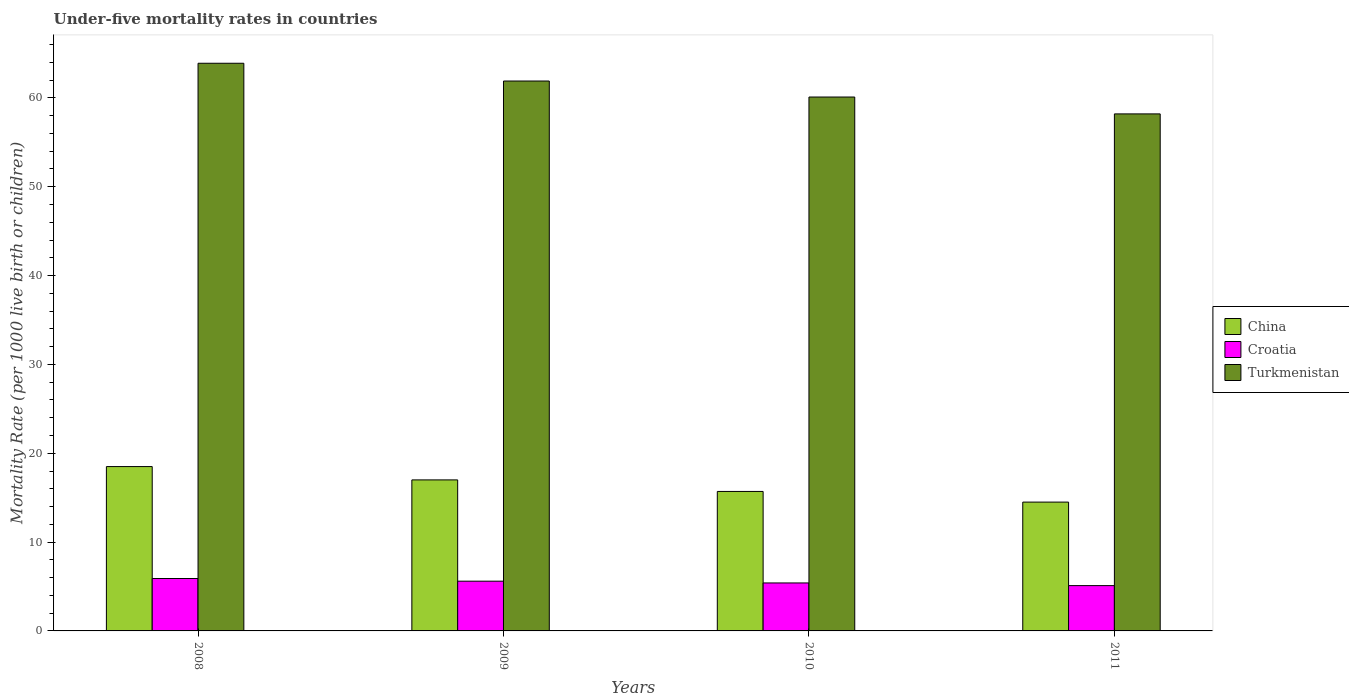How many groups of bars are there?
Give a very brief answer. 4. Are the number of bars per tick equal to the number of legend labels?
Offer a very short reply. Yes. Are the number of bars on each tick of the X-axis equal?
Make the answer very short. Yes. How many bars are there on the 1st tick from the left?
Give a very brief answer. 3. How many bars are there on the 4th tick from the right?
Ensure brevity in your answer.  3. What is the label of the 2nd group of bars from the left?
Keep it short and to the point. 2009. Across all years, what is the minimum under-five mortality rate in Croatia?
Offer a terse response. 5.1. In which year was the under-five mortality rate in Turkmenistan minimum?
Ensure brevity in your answer.  2011. What is the total under-five mortality rate in Turkmenistan in the graph?
Keep it short and to the point. 244.1. What is the difference between the under-five mortality rate in Turkmenistan in 2008 and the under-five mortality rate in China in 2011?
Ensure brevity in your answer.  49.4. What is the average under-five mortality rate in China per year?
Provide a succinct answer. 16.43. In the year 2011, what is the difference between the under-five mortality rate in Croatia and under-five mortality rate in China?
Offer a terse response. -9.4. What is the ratio of the under-five mortality rate in Croatia in 2008 to that in 2011?
Give a very brief answer. 1.16. Is the under-five mortality rate in Turkmenistan in 2009 less than that in 2010?
Your answer should be very brief. No. What is the difference between the highest and the second highest under-five mortality rate in China?
Your response must be concise. 1.5. What is the difference between the highest and the lowest under-five mortality rate in Croatia?
Provide a succinct answer. 0.8. Is the sum of the under-five mortality rate in Croatia in 2009 and 2011 greater than the maximum under-five mortality rate in China across all years?
Your answer should be compact. No. What does the 3rd bar from the left in 2010 represents?
Keep it short and to the point. Turkmenistan. What does the 1st bar from the right in 2010 represents?
Keep it short and to the point. Turkmenistan. How many years are there in the graph?
Give a very brief answer. 4. Are the values on the major ticks of Y-axis written in scientific E-notation?
Offer a terse response. No. Does the graph contain any zero values?
Ensure brevity in your answer.  No. Does the graph contain grids?
Your answer should be compact. No. Where does the legend appear in the graph?
Your response must be concise. Center right. What is the title of the graph?
Your answer should be compact. Under-five mortality rates in countries. Does "Korea (Democratic)" appear as one of the legend labels in the graph?
Offer a very short reply. No. What is the label or title of the Y-axis?
Make the answer very short. Mortality Rate (per 1000 live birth or children). What is the Mortality Rate (per 1000 live birth or children) in Turkmenistan in 2008?
Provide a short and direct response. 63.9. What is the Mortality Rate (per 1000 live birth or children) in Turkmenistan in 2009?
Your answer should be very brief. 61.9. What is the Mortality Rate (per 1000 live birth or children) of China in 2010?
Provide a short and direct response. 15.7. What is the Mortality Rate (per 1000 live birth or children) of Croatia in 2010?
Offer a very short reply. 5.4. What is the Mortality Rate (per 1000 live birth or children) of Turkmenistan in 2010?
Ensure brevity in your answer.  60.1. What is the Mortality Rate (per 1000 live birth or children) in China in 2011?
Your answer should be compact. 14.5. What is the Mortality Rate (per 1000 live birth or children) in Croatia in 2011?
Provide a succinct answer. 5.1. What is the Mortality Rate (per 1000 live birth or children) in Turkmenistan in 2011?
Offer a terse response. 58.2. Across all years, what is the maximum Mortality Rate (per 1000 live birth or children) of China?
Give a very brief answer. 18.5. Across all years, what is the maximum Mortality Rate (per 1000 live birth or children) in Croatia?
Provide a short and direct response. 5.9. Across all years, what is the maximum Mortality Rate (per 1000 live birth or children) in Turkmenistan?
Give a very brief answer. 63.9. Across all years, what is the minimum Mortality Rate (per 1000 live birth or children) of China?
Give a very brief answer. 14.5. Across all years, what is the minimum Mortality Rate (per 1000 live birth or children) of Croatia?
Your answer should be compact. 5.1. Across all years, what is the minimum Mortality Rate (per 1000 live birth or children) of Turkmenistan?
Your answer should be very brief. 58.2. What is the total Mortality Rate (per 1000 live birth or children) of China in the graph?
Your response must be concise. 65.7. What is the total Mortality Rate (per 1000 live birth or children) of Turkmenistan in the graph?
Provide a short and direct response. 244.1. What is the difference between the Mortality Rate (per 1000 live birth or children) of China in 2008 and that in 2009?
Give a very brief answer. 1.5. What is the difference between the Mortality Rate (per 1000 live birth or children) of Turkmenistan in 2008 and that in 2009?
Your answer should be compact. 2. What is the difference between the Mortality Rate (per 1000 live birth or children) of China in 2008 and that in 2010?
Provide a succinct answer. 2.8. What is the difference between the Mortality Rate (per 1000 live birth or children) in Turkmenistan in 2008 and that in 2010?
Offer a very short reply. 3.8. What is the difference between the Mortality Rate (per 1000 live birth or children) of China in 2008 and that in 2011?
Offer a terse response. 4. What is the difference between the Mortality Rate (per 1000 live birth or children) of China in 2009 and that in 2011?
Offer a very short reply. 2.5. What is the difference between the Mortality Rate (per 1000 live birth or children) in Turkmenistan in 2009 and that in 2011?
Offer a terse response. 3.7. What is the difference between the Mortality Rate (per 1000 live birth or children) in China in 2010 and that in 2011?
Your answer should be very brief. 1.2. What is the difference between the Mortality Rate (per 1000 live birth or children) in Croatia in 2010 and that in 2011?
Ensure brevity in your answer.  0.3. What is the difference between the Mortality Rate (per 1000 live birth or children) in Turkmenistan in 2010 and that in 2011?
Give a very brief answer. 1.9. What is the difference between the Mortality Rate (per 1000 live birth or children) of China in 2008 and the Mortality Rate (per 1000 live birth or children) of Turkmenistan in 2009?
Ensure brevity in your answer.  -43.4. What is the difference between the Mortality Rate (per 1000 live birth or children) in Croatia in 2008 and the Mortality Rate (per 1000 live birth or children) in Turkmenistan in 2009?
Give a very brief answer. -56. What is the difference between the Mortality Rate (per 1000 live birth or children) of China in 2008 and the Mortality Rate (per 1000 live birth or children) of Turkmenistan in 2010?
Your answer should be very brief. -41.6. What is the difference between the Mortality Rate (per 1000 live birth or children) in Croatia in 2008 and the Mortality Rate (per 1000 live birth or children) in Turkmenistan in 2010?
Provide a short and direct response. -54.2. What is the difference between the Mortality Rate (per 1000 live birth or children) in China in 2008 and the Mortality Rate (per 1000 live birth or children) in Turkmenistan in 2011?
Provide a succinct answer. -39.7. What is the difference between the Mortality Rate (per 1000 live birth or children) in Croatia in 2008 and the Mortality Rate (per 1000 live birth or children) in Turkmenistan in 2011?
Your response must be concise. -52.3. What is the difference between the Mortality Rate (per 1000 live birth or children) in China in 2009 and the Mortality Rate (per 1000 live birth or children) in Turkmenistan in 2010?
Offer a very short reply. -43.1. What is the difference between the Mortality Rate (per 1000 live birth or children) of Croatia in 2009 and the Mortality Rate (per 1000 live birth or children) of Turkmenistan in 2010?
Keep it short and to the point. -54.5. What is the difference between the Mortality Rate (per 1000 live birth or children) in China in 2009 and the Mortality Rate (per 1000 live birth or children) in Turkmenistan in 2011?
Keep it short and to the point. -41.2. What is the difference between the Mortality Rate (per 1000 live birth or children) in Croatia in 2009 and the Mortality Rate (per 1000 live birth or children) in Turkmenistan in 2011?
Your response must be concise. -52.6. What is the difference between the Mortality Rate (per 1000 live birth or children) in China in 2010 and the Mortality Rate (per 1000 live birth or children) in Croatia in 2011?
Give a very brief answer. 10.6. What is the difference between the Mortality Rate (per 1000 live birth or children) in China in 2010 and the Mortality Rate (per 1000 live birth or children) in Turkmenistan in 2011?
Your answer should be very brief. -42.5. What is the difference between the Mortality Rate (per 1000 live birth or children) of Croatia in 2010 and the Mortality Rate (per 1000 live birth or children) of Turkmenistan in 2011?
Your answer should be very brief. -52.8. What is the average Mortality Rate (per 1000 live birth or children) of China per year?
Your response must be concise. 16.43. What is the average Mortality Rate (per 1000 live birth or children) of Croatia per year?
Your response must be concise. 5.5. What is the average Mortality Rate (per 1000 live birth or children) of Turkmenistan per year?
Make the answer very short. 61.02. In the year 2008, what is the difference between the Mortality Rate (per 1000 live birth or children) in China and Mortality Rate (per 1000 live birth or children) in Croatia?
Offer a very short reply. 12.6. In the year 2008, what is the difference between the Mortality Rate (per 1000 live birth or children) in China and Mortality Rate (per 1000 live birth or children) in Turkmenistan?
Your answer should be very brief. -45.4. In the year 2008, what is the difference between the Mortality Rate (per 1000 live birth or children) of Croatia and Mortality Rate (per 1000 live birth or children) of Turkmenistan?
Provide a succinct answer. -58. In the year 2009, what is the difference between the Mortality Rate (per 1000 live birth or children) in China and Mortality Rate (per 1000 live birth or children) in Turkmenistan?
Make the answer very short. -44.9. In the year 2009, what is the difference between the Mortality Rate (per 1000 live birth or children) in Croatia and Mortality Rate (per 1000 live birth or children) in Turkmenistan?
Give a very brief answer. -56.3. In the year 2010, what is the difference between the Mortality Rate (per 1000 live birth or children) of China and Mortality Rate (per 1000 live birth or children) of Turkmenistan?
Offer a very short reply. -44.4. In the year 2010, what is the difference between the Mortality Rate (per 1000 live birth or children) of Croatia and Mortality Rate (per 1000 live birth or children) of Turkmenistan?
Provide a succinct answer. -54.7. In the year 2011, what is the difference between the Mortality Rate (per 1000 live birth or children) of China and Mortality Rate (per 1000 live birth or children) of Croatia?
Your response must be concise. 9.4. In the year 2011, what is the difference between the Mortality Rate (per 1000 live birth or children) in China and Mortality Rate (per 1000 live birth or children) in Turkmenistan?
Your response must be concise. -43.7. In the year 2011, what is the difference between the Mortality Rate (per 1000 live birth or children) of Croatia and Mortality Rate (per 1000 live birth or children) of Turkmenistan?
Your answer should be compact. -53.1. What is the ratio of the Mortality Rate (per 1000 live birth or children) in China in 2008 to that in 2009?
Keep it short and to the point. 1.09. What is the ratio of the Mortality Rate (per 1000 live birth or children) in Croatia in 2008 to that in 2009?
Provide a succinct answer. 1.05. What is the ratio of the Mortality Rate (per 1000 live birth or children) in Turkmenistan in 2008 to that in 2009?
Keep it short and to the point. 1.03. What is the ratio of the Mortality Rate (per 1000 live birth or children) in China in 2008 to that in 2010?
Keep it short and to the point. 1.18. What is the ratio of the Mortality Rate (per 1000 live birth or children) of Croatia in 2008 to that in 2010?
Offer a terse response. 1.09. What is the ratio of the Mortality Rate (per 1000 live birth or children) in Turkmenistan in 2008 to that in 2010?
Give a very brief answer. 1.06. What is the ratio of the Mortality Rate (per 1000 live birth or children) in China in 2008 to that in 2011?
Ensure brevity in your answer.  1.28. What is the ratio of the Mortality Rate (per 1000 live birth or children) of Croatia in 2008 to that in 2011?
Ensure brevity in your answer.  1.16. What is the ratio of the Mortality Rate (per 1000 live birth or children) of Turkmenistan in 2008 to that in 2011?
Make the answer very short. 1.1. What is the ratio of the Mortality Rate (per 1000 live birth or children) in China in 2009 to that in 2010?
Give a very brief answer. 1.08. What is the ratio of the Mortality Rate (per 1000 live birth or children) in Croatia in 2009 to that in 2010?
Offer a terse response. 1.04. What is the ratio of the Mortality Rate (per 1000 live birth or children) in Turkmenistan in 2009 to that in 2010?
Make the answer very short. 1.03. What is the ratio of the Mortality Rate (per 1000 live birth or children) in China in 2009 to that in 2011?
Your answer should be very brief. 1.17. What is the ratio of the Mortality Rate (per 1000 live birth or children) in Croatia in 2009 to that in 2011?
Keep it short and to the point. 1.1. What is the ratio of the Mortality Rate (per 1000 live birth or children) in Turkmenistan in 2009 to that in 2011?
Provide a succinct answer. 1.06. What is the ratio of the Mortality Rate (per 1000 live birth or children) of China in 2010 to that in 2011?
Give a very brief answer. 1.08. What is the ratio of the Mortality Rate (per 1000 live birth or children) in Croatia in 2010 to that in 2011?
Your response must be concise. 1.06. What is the ratio of the Mortality Rate (per 1000 live birth or children) of Turkmenistan in 2010 to that in 2011?
Your response must be concise. 1.03. What is the difference between the highest and the second highest Mortality Rate (per 1000 live birth or children) in Turkmenistan?
Offer a very short reply. 2. 